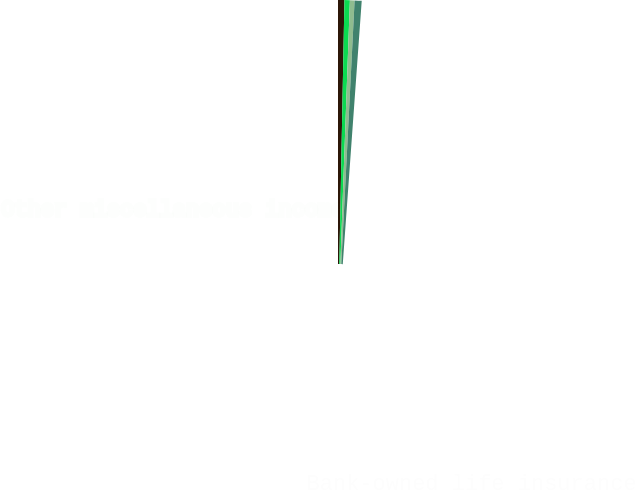Convert chart to OTSL. <chart><loc_0><loc_0><loc_500><loc_500><pie_chart><fcel>Insurance commissions and fees<fcel>Bank-owned life insurance<fcel>Commercial credit fee income<fcel>Other miscellaneous income<nl><fcel>27.15%<fcel>22.98%<fcel>19.84%<fcel>30.03%<nl></chart> 